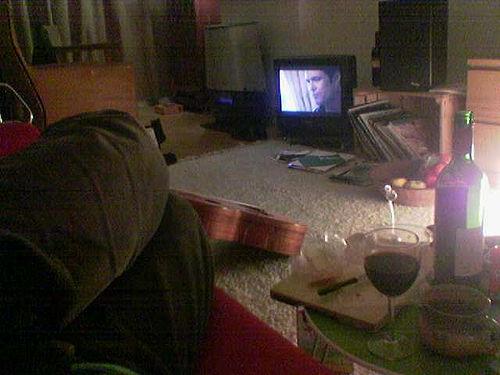Is there a wine glass on the stand?
Be succinct. Yes. Is the TV on?
Be succinct. Yes. Is there a man on the TV?
Short answer required. Yes. 